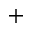<formula> <loc_0><loc_0><loc_500><loc_500>^ { + }</formula> 